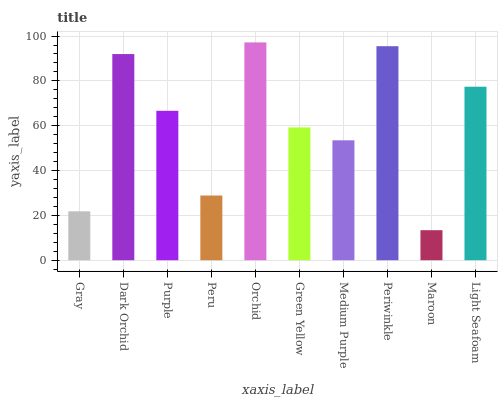Is Maroon the minimum?
Answer yes or no. Yes. Is Orchid the maximum?
Answer yes or no. Yes. Is Dark Orchid the minimum?
Answer yes or no. No. Is Dark Orchid the maximum?
Answer yes or no. No. Is Dark Orchid greater than Gray?
Answer yes or no. Yes. Is Gray less than Dark Orchid?
Answer yes or no. Yes. Is Gray greater than Dark Orchid?
Answer yes or no. No. Is Dark Orchid less than Gray?
Answer yes or no. No. Is Purple the high median?
Answer yes or no. Yes. Is Green Yellow the low median?
Answer yes or no. Yes. Is Periwinkle the high median?
Answer yes or no. No. Is Purple the low median?
Answer yes or no. No. 